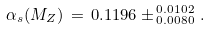Convert formula to latex. <formula><loc_0><loc_0><loc_500><loc_500>\alpha _ { s } ( M _ { Z } ) \, = \, 0 . 1 1 9 6 \pm ^ { \, 0 . 0 1 0 2 } _ { \, 0 . 0 0 8 0 } \, .</formula> 